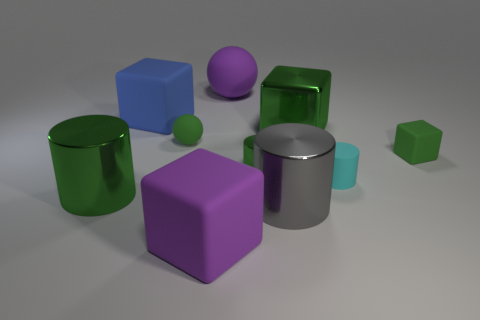Does the large gray metal object have the same shape as the cyan matte object?
Give a very brief answer. Yes. What number of big purple spheres are behind the large blue matte block on the left side of the gray cylinder?
Give a very brief answer. 1. The blue rubber thing is what shape?
Your response must be concise. Cube. The big blue object that is made of the same material as the small cyan object is what shape?
Make the answer very short. Cube. There is a tiny green matte object that is right of the tiny cyan rubber object; does it have the same shape as the tiny green shiny object?
Your response must be concise. No. There is a large gray shiny object right of the large purple matte sphere; what is its shape?
Offer a very short reply. Cylinder. There is a rubber thing that is the same color as the small matte cube; what shape is it?
Your answer should be very brief. Sphere. How many gray metallic cylinders have the same size as the cyan cylinder?
Keep it short and to the point. 0. The tiny metal object has what color?
Offer a terse response. Green. Does the big metallic block have the same color as the matte block in front of the large gray metal object?
Your answer should be very brief. No. 